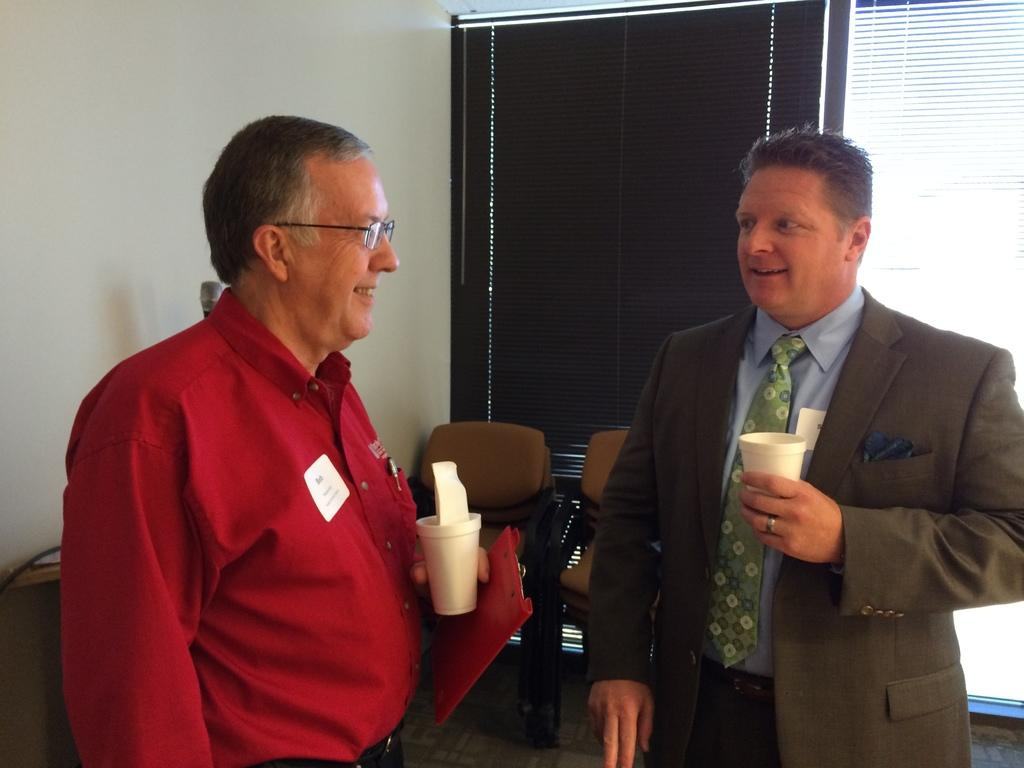How many people are in the image? There are two persons in the image. What are the persons doing in the image? The persons are standing and smiling. What are the persons holding in the image? The persons are holding glasses. What can be seen in the background of the image? There are chairs, window shutters, and a wall in the background of the image. What type of bottle is the person teaching in the image? There is no bottle or teaching activity present in the image. How does the person express their feelings of hate in the image? There is no expression of hate in the image; the persons are standing and smiling. 